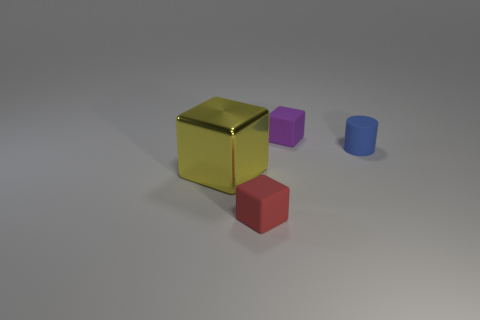Is there any other thing that has the same material as the big yellow thing?
Your answer should be very brief. No. Is there any other thing that has the same size as the shiny cube?
Give a very brief answer. No. Do the matte object that is to the left of the purple matte cube and the yellow shiny object have the same size?
Provide a short and direct response. No. How many other things are the same material as the red object?
Provide a succinct answer. 2. Are there an equal number of yellow things that are in front of the large yellow thing and big metal things that are in front of the blue object?
Provide a short and direct response. No. What color is the small cube to the left of the small block to the right of the small cube in front of the tiny rubber cylinder?
Offer a very short reply. Red. There is a tiny rubber object that is in front of the yellow metallic cube; what shape is it?
Your response must be concise. Cube. What shape is the tiny blue thing that is made of the same material as the purple thing?
Give a very brief answer. Cylinder. Is there any other thing that has the same shape as the blue object?
Offer a very short reply. No. There is a big metal cube; what number of tiny things are in front of it?
Ensure brevity in your answer.  1. 